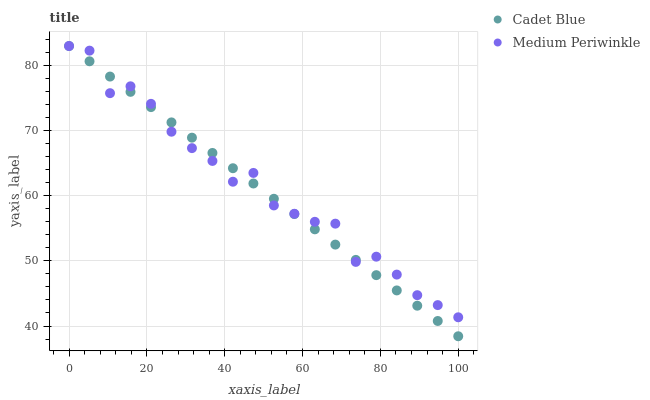Does Cadet Blue have the minimum area under the curve?
Answer yes or no. Yes. Does Medium Periwinkle have the maximum area under the curve?
Answer yes or no. Yes. Does Medium Periwinkle have the minimum area under the curve?
Answer yes or no. No. Is Cadet Blue the smoothest?
Answer yes or no. Yes. Is Medium Periwinkle the roughest?
Answer yes or no. Yes. Is Medium Periwinkle the smoothest?
Answer yes or no. No. Does Cadet Blue have the lowest value?
Answer yes or no. Yes. Does Medium Periwinkle have the lowest value?
Answer yes or no. No. Does Medium Periwinkle have the highest value?
Answer yes or no. Yes. Does Cadet Blue intersect Medium Periwinkle?
Answer yes or no. Yes. Is Cadet Blue less than Medium Periwinkle?
Answer yes or no. No. Is Cadet Blue greater than Medium Periwinkle?
Answer yes or no. No. 